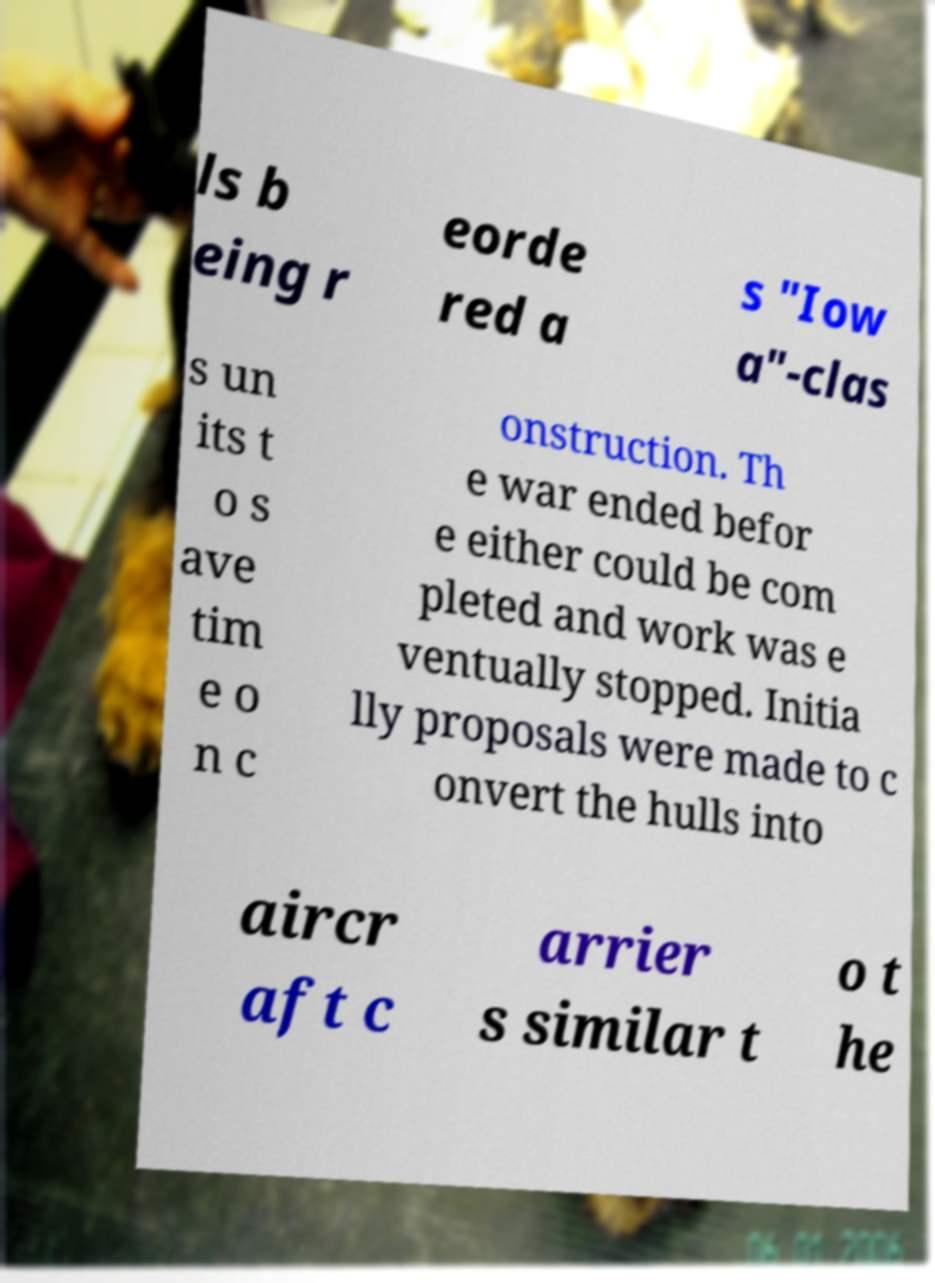Could you extract and type out the text from this image? ls b eing r eorde red a s "Iow a"-clas s un its t o s ave tim e o n c onstruction. Th e war ended befor e either could be com pleted and work was e ventually stopped. Initia lly proposals were made to c onvert the hulls into aircr aft c arrier s similar t o t he 